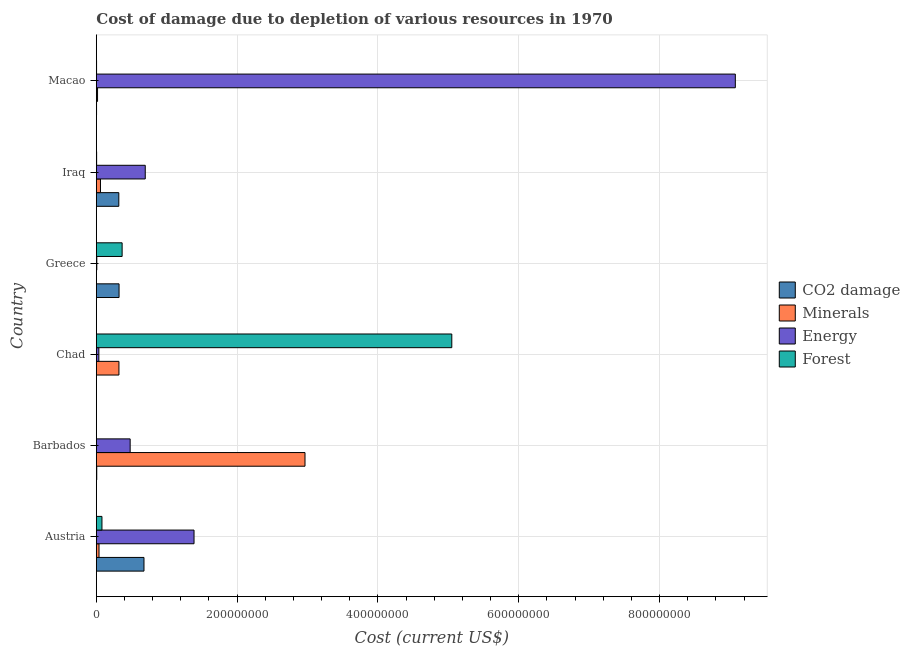Are the number of bars on each tick of the Y-axis equal?
Give a very brief answer. Yes. What is the cost of damage due to depletion of forests in Iraq?
Your answer should be compact. 3.97e+05. Across all countries, what is the maximum cost of damage due to depletion of forests?
Ensure brevity in your answer.  5.05e+08. Across all countries, what is the minimum cost of damage due to depletion of coal?
Provide a short and direct response. 1.66e+05. In which country was the cost of damage due to depletion of coal maximum?
Your response must be concise. Austria. In which country was the cost of damage due to depletion of coal minimum?
Your answer should be compact. Chad. What is the total cost of damage due to depletion of energy in the graph?
Your answer should be very brief. 1.17e+09. What is the difference between the cost of damage due to depletion of minerals in Iraq and that in Macao?
Offer a terse response. 4.15e+06. What is the difference between the cost of damage due to depletion of energy in Austria and the cost of damage due to depletion of forests in Greece?
Offer a terse response. 1.02e+08. What is the average cost of damage due to depletion of coal per country?
Your answer should be compact. 2.21e+07. What is the difference between the cost of damage due to depletion of coal and cost of damage due to depletion of minerals in Iraq?
Your answer should be very brief. 2.61e+07. What is the ratio of the cost of damage due to depletion of coal in Iraq to that in Macao?
Your answer should be compact. 116.43. Is the cost of damage due to depletion of coal in Barbados less than that in Greece?
Your answer should be compact. Yes. Is the difference between the cost of damage due to depletion of minerals in Barbados and Chad greater than the difference between the cost of damage due to depletion of coal in Barbados and Chad?
Offer a terse response. Yes. What is the difference between the highest and the second highest cost of damage due to depletion of coal?
Offer a very short reply. 3.54e+07. What is the difference between the highest and the lowest cost of damage due to depletion of energy?
Keep it short and to the point. 9.07e+08. Is the sum of the cost of damage due to depletion of energy in Chad and Greece greater than the maximum cost of damage due to depletion of minerals across all countries?
Keep it short and to the point. No. What does the 2nd bar from the top in Macao represents?
Keep it short and to the point. Energy. What does the 4th bar from the bottom in Iraq represents?
Offer a very short reply. Forest. Are all the bars in the graph horizontal?
Make the answer very short. Yes. What is the title of the graph?
Keep it short and to the point. Cost of damage due to depletion of various resources in 1970 . What is the label or title of the X-axis?
Give a very brief answer. Cost (current US$). What is the label or title of the Y-axis?
Give a very brief answer. Country. What is the Cost (current US$) in CO2 damage in Austria?
Your answer should be very brief. 6.77e+07. What is the Cost (current US$) in Minerals in Austria?
Ensure brevity in your answer.  3.80e+06. What is the Cost (current US$) in Energy in Austria?
Offer a terse response. 1.39e+08. What is the Cost (current US$) in Forest in Austria?
Your answer should be compact. 7.95e+06. What is the Cost (current US$) in CO2 damage in Barbados?
Ensure brevity in your answer.  5.73e+05. What is the Cost (current US$) of Minerals in Barbados?
Your response must be concise. 2.96e+08. What is the Cost (current US$) of Energy in Barbados?
Keep it short and to the point. 4.80e+07. What is the Cost (current US$) in Forest in Barbados?
Your response must be concise. 3.70e+04. What is the Cost (current US$) of CO2 damage in Chad?
Keep it short and to the point. 1.66e+05. What is the Cost (current US$) of Minerals in Chad?
Offer a terse response. 3.21e+07. What is the Cost (current US$) of Energy in Chad?
Offer a terse response. 3.56e+06. What is the Cost (current US$) of Forest in Chad?
Give a very brief answer. 5.05e+08. What is the Cost (current US$) of CO2 damage in Greece?
Offer a very short reply. 3.23e+07. What is the Cost (current US$) of Minerals in Greece?
Ensure brevity in your answer.  1.05e+05. What is the Cost (current US$) of Energy in Greece?
Your response must be concise. 6.65e+05. What is the Cost (current US$) in Forest in Greece?
Provide a short and direct response. 3.66e+07. What is the Cost (current US$) of CO2 damage in Iraq?
Your answer should be very brief. 3.19e+07. What is the Cost (current US$) of Minerals in Iraq?
Provide a short and direct response. 5.85e+06. What is the Cost (current US$) in Energy in Iraq?
Give a very brief answer. 6.95e+07. What is the Cost (current US$) in Forest in Iraq?
Offer a very short reply. 3.97e+05. What is the Cost (current US$) of CO2 damage in Macao?
Ensure brevity in your answer.  2.74e+05. What is the Cost (current US$) in Minerals in Macao?
Your answer should be compact. 1.70e+06. What is the Cost (current US$) in Energy in Macao?
Your response must be concise. 9.08e+08. What is the Cost (current US$) in Forest in Macao?
Make the answer very short. 3.14e+05. Across all countries, what is the maximum Cost (current US$) in CO2 damage?
Offer a very short reply. 6.77e+07. Across all countries, what is the maximum Cost (current US$) of Minerals?
Offer a very short reply. 2.96e+08. Across all countries, what is the maximum Cost (current US$) in Energy?
Your response must be concise. 9.08e+08. Across all countries, what is the maximum Cost (current US$) in Forest?
Provide a short and direct response. 5.05e+08. Across all countries, what is the minimum Cost (current US$) in CO2 damage?
Ensure brevity in your answer.  1.66e+05. Across all countries, what is the minimum Cost (current US$) in Minerals?
Your answer should be very brief. 1.05e+05. Across all countries, what is the minimum Cost (current US$) in Energy?
Give a very brief answer. 6.65e+05. Across all countries, what is the minimum Cost (current US$) in Forest?
Provide a succinct answer. 3.70e+04. What is the total Cost (current US$) of CO2 damage in the graph?
Offer a very short reply. 1.33e+08. What is the total Cost (current US$) in Minerals in the graph?
Your answer should be very brief. 3.40e+08. What is the total Cost (current US$) in Energy in the graph?
Give a very brief answer. 1.17e+09. What is the total Cost (current US$) of Forest in the graph?
Make the answer very short. 5.50e+08. What is the difference between the Cost (current US$) of CO2 damage in Austria and that in Barbados?
Keep it short and to the point. 6.71e+07. What is the difference between the Cost (current US$) of Minerals in Austria and that in Barbados?
Your response must be concise. -2.93e+08. What is the difference between the Cost (current US$) of Energy in Austria and that in Barbados?
Offer a terse response. 9.07e+07. What is the difference between the Cost (current US$) in Forest in Austria and that in Barbados?
Provide a short and direct response. 7.92e+06. What is the difference between the Cost (current US$) of CO2 damage in Austria and that in Chad?
Provide a short and direct response. 6.75e+07. What is the difference between the Cost (current US$) in Minerals in Austria and that in Chad?
Your response must be concise. -2.83e+07. What is the difference between the Cost (current US$) of Energy in Austria and that in Chad?
Provide a succinct answer. 1.35e+08. What is the difference between the Cost (current US$) in Forest in Austria and that in Chad?
Your answer should be compact. -4.97e+08. What is the difference between the Cost (current US$) in CO2 damage in Austria and that in Greece?
Give a very brief answer. 3.54e+07. What is the difference between the Cost (current US$) in Minerals in Austria and that in Greece?
Provide a short and direct response. 3.69e+06. What is the difference between the Cost (current US$) in Energy in Austria and that in Greece?
Offer a terse response. 1.38e+08. What is the difference between the Cost (current US$) of Forest in Austria and that in Greece?
Give a very brief answer. -2.87e+07. What is the difference between the Cost (current US$) of CO2 damage in Austria and that in Iraq?
Give a very brief answer. 3.58e+07. What is the difference between the Cost (current US$) in Minerals in Austria and that in Iraq?
Ensure brevity in your answer.  -2.06e+06. What is the difference between the Cost (current US$) of Energy in Austria and that in Iraq?
Keep it short and to the point. 6.93e+07. What is the difference between the Cost (current US$) in Forest in Austria and that in Iraq?
Your answer should be very brief. 7.55e+06. What is the difference between the Cost (current US$) of CO2 damage in Austria and that in Macao?
Your answer should be compact. 6.74e+07. What is the difference between the Cost (current US$) in Minerals in Austria and that in Macao?
Your response must be concise. 2.10e+06. What is the difference between the Cost (current US$) of Energy in Austria and that in Macao?
Make the answer very short. -7.69e+08. What is the difference between the Cost (current US$) of Forest in Austria and that in Macao?
Provide a short and direct response. 7.64e+06. What is the difference between the Cost (current US$) of CO2 damage in Barbados and that in Chad?
Provide a succinct answer. 4.06e+05. What is the difference between the Cost (current US$) of Minerals in Barbados and that in Chad?
Keep it short and to the point. 2.64e+08. What is the difference between the Cost (current US$) in Energy in Barbados and that in Chad?
Your response must be concise. 4.45e+07. What is the difference between the Cost (current US$) in Forest in Barbados and that in Chad?
Ensure brevity in your answer.  -5.05e+08. What is the difference between the Cost (current US$) in CO2 damage in Barbados and that in Greece?
Your response must be concise. -3.17e+07. What is the difference between the Cost (current US$) of Minerals in Barbados and that in Greece?
Ensure brevity in your answer.  2.96e+08. What is the difference between the Cost (current US$) in Energy in Barbados and that in Greece?
Offer a terse response. 4.74e+07. What is the difference between the Cost (current US$) of Forest in Barbados and that in Greece?
Keep it short and to the point. -3.66e+07. What is the difference between the Cost (current US$) of CO2 damage in Barbados and that in Iraq?
Offer a very short reply. -3.13e+07. What is the difference between the Cost (current US$) of Minerals in Barbados and that in Iraq?
Give a very brief answer. 2.91e+08. What is the difference between the Cost (current US$) in Energy in Barbados and that in Iraq?
Make the answer very short. -2.14e+07. What is the difference between the Cost (current US$) of Forest in Barbados and that in Iraq?
Make the answer very short. -3.60e+05. What is the difference between the Cost (current US$) of CO2 damage in Barbados and that in Macao?
Ensure brevity in your answer.  2.99e+05. What is the difference between the Cost (current US$) in Minerals in Barbados and that in Macao?
Your answer should be compact. 2.95e+08. What is the difference between the Cost (current US$) in Energy in Barbados and that in Macao?
Provide a succinct answer. -8.60e+08. What is the difference between the Cost (current US$) of Forest in Barbados and that in Macao?
Offer a very short reply. -2.76e+05. What is the difference between the Cost (current US$) in CO2 damage in Chad and that in Greece?
Offer a terse response. -3.21e+07. What is the difference between the Cost (current US$) in Minerals in Chad and that in Greece?
Make the answer very short. 3.20e+07. What is the difference between the Cost (current US$) of Energy in Chad and that in Greece?
Provide a short and direct response. 2.90e+06. What is the difference between the Cost (current US$) in Forest in Chad and that in Greece?
Give a very brief answer. 4.68e+08. What is the difference between the Cost (current US$) of CO2 damage in Chad and that in Iraq?
Ensure brevity in your answer.  -3.17e+07. What is the difference between the Cost (current US$) of Minerals in Chad and that in Iraq?
Your answer should be compact. 2.62e+07. What is the difference between the Cost (current US$) of Energy in Chad and that in Iraq?
Offer a terse response. -6.59e+07. What is the difference between the Cost (current US$) of Forest in Chad and that in Iraq?
Give a very brief answer. 5.05e+08. What is the difference between the Cost (current US$) of CO2 damage in Chad and that in Macao?
Your response must be concise. -1.08e+05. What is the difference between the Cost (current US$) of Minerals in Chad and that in Macao?
Provide a short and direct response. 3.04e+07. What is the difference between the Cost (current US$) in Energy in Chad and that in Macao?
Make the answer very short. -9.04e+08. What is the difference between the Cost (current US$) of Forest in Chad and that in Macao?
Provide a succinct answer. 5.05e+08. What is the difference between the Cost (current US$) in CO2 damage in Greece and that in Iraq?
Ensure brevity in your answer.  3.43e+05. What is the difference between the Cost (current US$) in Minerals in Greece and that in Iraq?
Offer a terse response. -5.75e+06. What is the difference between the Cost (current US$) of Energy in Greece and that in Iraq?
Ensure brevity in your answer.  -6.88e+07. What is the difference between the Cost (current US$) in Forest in Greece and that in Iraq?
Ensure brevity in your answer.  3.62e+07. What is the difference between the Cost (current US$) of CO2 damage in Greece and that in Macao?
Ensure brevity in your answer.  3.20e+07. What is the difference between the Cost (current US$) in Minerals in Greece and that in Macao?
Keep it short and to the point. -1.59e+06. What is the difference between the Cost (current US$) in Energy in Greece and that in Macao?
Offer a very short reply. -9.07e+08. What is the difference between the Cost (current US$) in Forest in Greece and that in Macao?
Provide a short and direct response. 3.63e+07. What is the difference between the Cost (current US$) of CO2 damage in Iraq and that in Macao?
Ensure brevity in your answer.  3.16e+07. What is the difference between the Cost (current US$) in Minerals in Iraq and that in Macao?
Offer a terse response. 4.15e+06. What is the difference between the Cost (current US$) of Energy in Iraq and that in Macao?
Ensure brevity in your answer.  -8.38e+08. What is the difference between the Cost (current US$) in Forest in Iraq and that in Macao?
Provide a short and direct response. 8.39e+04. What is the difference between the Cost (current US$) of CO2 damage in Austria and the Cost (current US$) of Minerals in Barbados?
Your answer should be very brief. -2.29e+08. What is the difference between the Cost (current US$) of CO2 damage in Austria and the Cost (current US$) of Energy in Barbados?
Your response must be concise. 1.96e+07. What is the difference between the Cost (current US$) of CO2 damage in Austria and the Cost (current US$) of Forest in Barbados?
Make the answer very short. 6.76e+07. What is the difference between the Cost (current US$) of Minerals in Austria and the Cost (current US$) of Energy in Barbados?
Your answer should be compact. -4.42e+07. What is the difference between the Cost (current US$) of Minerals in Austria and the Cost (current US$) of Forest in Barbados?
Your answer should be compact. 3.76e+06. What is the difference between the Cost (current US$) of Energy in Austria and the Cost (current US$) of Forest in Barbados?
Your answer should be compact. 1.39e+08. What is the difference between the Cost (current US$) in CO2 damage in Austria and the Cost (current US$) in Minerals in Chad?
Keep it short and to the point. 3.56e+07. What is the difference between the Cost (current US$) of CO2 damage in Austria and the Cost (current US$) of Energy in Chad?
Offer a terse response. 6.41e+07. What is the difference between the Cost (current US$) of CO2 damage in Austria and the Cost (current US$) of Forest in Chad?
Give a very brief answer. -4.37e+08. What is the difference between the Cost (current US$) of Minerals in Austria and the Cost (current US$) of Energy in Chad?
Offer a terse response. 2.34e+05. What is the difference between the Cost (current US$) in Minerals in Austria and the Cost (current US$) in Forest in Chad?
Keep it short and to the point. -5.01e+08. What is the difference between the Cost (current US$) in Energy in Austria and the Cost (current US$) in Forest in Chad?
Offer a very short reply. -3.66e+08. What is the difference between the Cost (current US$) of CO2 damage in Austria and the Cost (current US$) of Minerals in Greece?
Provide a succinct answer. 6.76e+07. What is the difference between the Cost (current US$) of CO2 damage in Austria and the Cost (current US$) of Energy in Greece?
Ensure brevity in your answer.  6.70e+07. What is the difference between the Cost (current US$) in CO2 damage in Austria and the Cost (current US$) in Forest in Greece?
Provide a short and direct response. 3.10e+07. What is the difference between the Cost (current US$) of Minerals in Austria and the Cost (current US$) of Energy in Greece?
Make the answer very short. 3.13e+06. What is the difference between the Cost (current US$) of Minerals in Austria and the Cost (current US$) of Forest in Greece?
Offer a very short reply. -3.28e+07. What is the difference between the Cost (current US$) in Energy in Austria and the Cost (current US$) in Forest in Greece?
Provide a short and direct response. 1.02e+08. What is the difference between the Cost (current US$) in CO2 damage in Austria and the Cost (current US$) in Minerals in Iraq?
Your answer should be compact. 6.18e+07. What is the difference between the Cost (current US$) in CO2 damage in Austria and the Cost (current US$) in Energy in Iraq?
Ensure brevity in your answer.  -1.80e+06. What is the difference between the Cost (current US$) of CO2 damage in Austria and the Cost (current US$) of Forest in Iraq?
Your answer should be compact. 6.73e+07. What is the difference between the Cost (current US$) in Minerals in Austria and the Cost (current US$) in Energy in Iraq?
Your answer should be compact. -6.57e+07. What is the difference between the Cost (current US$) in Minerals in Austria and the Cost (current US$) in Forest in Iraq?
Provide a short and direct response. 3.40e+06. What is the difference between the Cost (current US$) in Energy in Austria and the Cost (current US$) in Forest in Iraq?
Your answer should be compact. 1.38e+08. What is the difference between the Cost (current US$) in CO2 damage in Austria and the Cost (current US$) in Minerals in Macao?
Make the answer very short. 6.60e+07. What is the difference between the Cost (current US$) of CO2 damage in Austria and the Cost (current US$) of Energy in Macao?
Make the answer very short. -8.40e+08. What is the difference between the Cost (current US$) of CO2 damage in Austria and the Cost (current US$) of Forest in Macao?
Offer a very short reply. 6.74e+07. What is the difference between the Cost (current US$) of Minerals in Austria and the Cost (current US$) of Energy in Macao?
Provide a short and direct response. -9.04e+08. What is the difference between the Cost (current US$) of Minerals in Austria and the Cost (current US$) of Forest in Macao?
Ensure brevity in your answer.  3.48e+06. What is the difference between the Cost (current US$) of Energy in Austria and the Cost (current US$) of Forest in Macao?
Offer a very short reply. 1.38e+08. What is the difference between the Cost (current US$) in CO2 damage in Barbados and the Cost (current US$) in Minerals in Chad?
Give a very brief answer. -3.15e+07. What is the difference between the Cost (current US$) in CO2 damage in Barbados and the Cost (current US$) in Energy in Chad?
Offer a very short reply. -2.99e+06. What is the difference between the Cost (current US$) of CO2 damage in Barbados and the Cost (current US$) of Forest in Chad?
Keep it short and to the point. -5.04e+08. What is the difference between the Cost (current US$) in Minerals in Barbados and the Cost (current US$) in Energy in Chad?
Ensure brevity in your answer.  2.93e+08. What is the difference between the Cost (current US$) of Minerals in Barbados and the Cost (current US$) of Forest in Chad?
Offer a very short reply. -2.09e+08. What is the difference between the Cost (current US$) in Energy in Barbados and the Cost (current US$) in Forest in Chad?
Give a very brief answer. -4.57e+08. What is the difference between the Cost (current US$) of CO2 damage in Barbados and the Cost (current US$) of Minerals in Greece?
Your answer should be compact. 4.68e+05. What is the difference between the Cost (current US$) of CO2 damage in Barbados and the Cost (current US$) of Energy in Greece?
Offer a terse response. -9.19e+04. What is the difference between the Cost (current US$) of CO2 damage in Barbados and the Cost (current US$) of Forest in Greece?
Your answer should be compact. -3.61e+07. What is the difference between the Cost (current US$) in Minerals in Barbados and the Cost (current US$) in Energy in Greece?
Offer a very short reply. 2.96e+08. What is the difference between the Cost (current US$) of Minerals in Barbados and the Cost (current US$) of Forest in Greece?
Offer a terse response. 2.60e+08. What is the difference between the Cost (current US$) of Energy in Barbados and the Cost (current US$) of Forest in Greece?
Your answer should be compact. 1.14e+07. What is the difference between the Cost (current US$) of CO2 damage in Barbados and the Cost (current US$) of Minerals in Iraq?
Your answer should be compact. -5.28e+06. What is the difference between the Cost (current US$) of CO2 damage in Barbados and the Cost (current US$) of Energy in Iraq?
Offer a terse response. -6.89e+07. What is the difference between the Cost (current US$) of CO2 damage in Barbados and the Cost (current US$) of Forest in Iraq?
Your answer should be very brief. 1.75e+05. What is the difference between the Cost (current US$) in Minerals in Barbados and the Cost (current US$) in Energy in Iraq?
Make the answer very short. 2.27e+08. What is the difference between the Cost (current US$) of Minerals in Barbados and the Cost (current US$) of Forest in Iraq?
Give a very brief answer. 2.96e+08. What is the difference between the Cost (current US$) of Energy in Barbados and the Cost (current US$) of Forest in Iraq?
Provide a succinct answer. 4.76e+07. What is the difference between the Cost (current US$) of CO2 damage in Barbados and the Cost (current US$) of Minerals in Macao?
Your answer should be compact. -1.12e+06. What is the difference between the Cost (current US$) in CO2 damage in Barbados and the Cost (current US$) in Energy in Macao?
Make the answer very short. -9.07e+08. What is the difference between the Cost (current US$) of CO2 damage in Barbados and the Cost (current US$) of Forest in Macao?
Provide a succinct answer. 2.59e+05. What is the difference between the Cost (current US$) in Minerals in Barbados and the Cost (current US$) in Energy in Macao?
Offer a terse response. -6.11e+08. What is the difference between the Cost (current US$) in Minerals in Barbados and the Cost (current US$) in Forest in Macao?
Your answer should be compact. 2.96e+08. What is the difference between the Cost (current US$) of Energy in Barbados and the Cost (current US$) of Forest in Macao?
Provide a short and direct response. 4.77e+07. What is the difference between the Cost (current US$) in CO2 damage in Chad and the Cost (current US$) in Minerals in Greece?
Ensure brevity in your answer.  6.16e+04. What is the difference between the Cost (current US$) of CO2 damage in Chad and the Cost (current US$) of Energy in Greece?
Your answer should be compact. -4.98e+05. What is the difference between the Cost (current US$) of CO2 damage in Chad and the Cost (current US$) of Forest in Greece?
Your answer should be compact. -3.65e+07. What is the difference between the Cost (current US$) in Minerals in Chad and the Cost (current US$) in Energy in Greece?
Offer a very short reply. 3.14e+07. What is the difference between the Cost (current US$) in Minerals in Chad and the Cost (current US$) in Forest in Greece?
Ensure brevity in your answer.  -4.53e+06. What is the difference between the Cost (current US$) in Energy in Chad and the Cost (current US$) in Forest in Greece?
Your answer should be very brief. -3.31e+07. What is the difference between the Cost (current US$) of CO2 damage in Chad and the Cost (current US$) of Minerals in Iraq?
Offer a very short reply. -5.69e+06. What is the difference between the Cost (current US$) in CO2 damage in Chad and the Cost (current US$) in Energy in Iraq?
Keep it short and to the point. -6.93e+07. What is the difference between the Cost (current US$) in CO2 damage in Chad and the Cost (current US$) in Forest in Iraq?
Provide a short and direct response. -2.31e+05. What is the difference between the Cost (current US$) of Minerals in Chad and the Cost (current US$) of Energy in Iraq?
Keep it short and to the point. -3.74e+07. What is the difference between the Cost (current US$) in Minerals in Chad and the Cost (current US$) in Forest in Iraq?
Your answer should be compact. 3.17e+07. What is the difference between the Cost (current US$) in Energy in Chad and the Cost (current US$) in Forest in Iraq?
Ensure brevity in your answer.  3.17e+06. What is the difference between the Cost (current US$) in CO2 damage in Chad and the Cost (current US$) in Minerals in Macao?
Offer a very short reply. -1.53e+06. What is the difference between the Cost (current US$) of CO2 damage in Chad and the Cost (current US$) of Energy in Macao?
Ensure brevity in your answer.  -9.07e+08. What is the difference between the Cost (current US$) in CO2 damage in Chad and the Cost (current US$) in Forest in Macao?
Offer a very short reply. -1.47e+05. What is the difference between the Cost (current US$) in Minerals in Chad and the Cost (current US$) in Energy in Macao?
Offer a terse response. -8.76e+08. What is the difference between the Cost (current US$) of Minerals in Chad and the Cost (current US$) of Forest in Macao?
Offer a terse response. 3.18e+07. What is the difference between the Cost (current US$) of Energy in Chad and the Cost (current US$) of Forest in Macao?
Keep it short and to the point. 3.25e+06. What is the difference between the Cost (current US$) of CO2 damage in Greece and the Cost (current US$) of Minerals in Iraq?
Your answer should be very brief. 2.64e+07. What is the difference between the Cost (current US$) of CO2 damage in Greece and the Cost (current US$) of Energy in Iraq?
Provide a short and direct response. -3.72e+07. What is the difference between the Cost (current US$) of CO2 damage in Greece and the Cost (current US$) of Forest in Iraq?
Make the answer very short. 3.19e+07. What is the difference between the Cost (current US$) in Minerals in Greece and the Cost (current US$) in Energy in Iraq?
Your response must be concise. -6.94e+07. What is the difference between the Cost (current US$) in Minerals in Greece and the Cost (current US$) in Forest in Iraq?
Offer a terse response. -2.93e+05. What is the difference between the Cost (current US$) in Energy in Greece and the Cost (current US$) in Forest in Iraq?
Give a very brief answer. 2.67e+05. What is the difference between the Cost (current US$) of CO2 damage in Greece and the Cost (current US$) of Minerals in Macao?
Your answer should be compact. 3.06e+07. What is the difference between the Cost (current US$) in CO2 damage in Greece and the Cost (current US$) in Energy in Macao?
Ensure brevity in your answer.  -8.75e+08. What is the difference between the Cost (current US$) of CO2 damage in Greece and the Cost (current US$) of Forest in Macao?
Your answer should be very brief. 3.19e+07. What is the difference between the Cost (current US$) in Minerals in Greece and the Cost (current US$) in Energy in Macao?
Ensure brevity in your answer.  -9.08e+08. What is the difference between the Cost (current US$) in Minerals in Greece and the Cost (current US$) in Forest in Macao?
Make the answer very short. -2.09e+05. What is the difference between the Cost (current US$) in Energy in Greece and the Cost (current US$) in Forest in Macao?
Offer a terse response. 3.51e+05. What is the difference between the Cost (current US$) in CO2 damage in Iraq and the Cost (current US$) in Minerals in Macao?
Ensure brevity in your answer.  3.02e+07. What is the difference between the Cost (current US$) in CO2 damage in Iraq and the Cost (current US$) in Energy in Macao?
Give a very brief answer. -8.76e+08. What is the difference between the Cost (current US$) of CO2 damage in Iraq and the Cost (current US$) of Forest in Macao?
Provide a short and direct response. 3.16e+07. What is the difference between the Cost (current US$) of Minerals in Iraq and the Cost (current US$) of Energy in Macao?
Your answer should be compact. -9.02e+08. What is the difference between the Cost (current US$) of Minerals in Iraq and the Cost (current US$) of Forest in Macao?
Give a very brief answer. 5.54e+06. What is the difference between the Cost (current US$) in Energy in Iraq and the Cost (current US$) in Forest in Macao?
Your answer should be compact. 6.92e+07. What is the average Cost (current US$) in CO2 damage per country?
Offer a terse response. 2.21e+07. What is the average Cost (current US$) of Minerals per country?
Give a very brief answer. 5.67e+07. What is the average Cost (current US$) in Energy per country?
Provide a succinct answer. 1.95e+08. What is the average Cost (current US$) of Forest per country?
Offer a terse response. 9.17e+07. What is the difference between the Cost (current US$) in CO2 damage and Cost (current US$) in Minerals in Austria?
Your answer should be very brief. 6.39e+07. What is the difference between the Cost (current US$) of CO2 damage and Cost (current US$) of Energy in Austria?
Ensure brevity in your answer.  -7.11e+07. What is the difference between the Cost (current US$) in CO2 damage and Cost (current US$) in Forest in Austria?
Give a very brief answer. 5.97e+07. What is the difference between the Cost (current US$) in Minerals and Cost (current US$) in Energy in Austria?
Keep it short and to the point. -1.35e+08. What is the difference between the Cost (current US$) of Minerals and Cost (current US$) of Forest in Austria?
Your answer should be compact. -4.16e+06. What is the difference between the Cost (current US$) of Energy and Cost (current US$) of Forest in Austria?
Your answer should be compact. 1.31e+08. What is the difference between the Cost (current US$) in CO2 damage and Cost (current US$) in Minerals in Barbados?
Ensure brevity in your answer.  -2.96e+08. What is the difference between the Cost (current US$) in CO2 damage and Cost (current US$) in Energy in Barbados?
Provide a short and direct response. -4.75e+07. What is the difference between the Cost (current US$) in CO2 damage and Cost (current US$) in Forest in Barbados?
Provide a short and direct response. 5.36e+05. What is the difference between the Cost (current US$) in Minerals and Cost (current US$) in Energy in Barbados?
Provide a succinct answer. 2.48e+08. What is the difference between the Cost (current US$) of Minerals and Cost (current US$) of Forest in Barbados?
Keep it short and to the point. 2.96e+08. What is the difference between the Cost (current US$) in Energy and Cost (current US$) in Forest in Barbados?
Keep it short and to the point. 4.80e+07. What is the difference between the Cost (current US$) in CO2 damage and Cost (current US$) in Minerals in Chad?
Provide a succinct answer. -3.19e+07. What is the difference between the Cost (current US$) in CO2 damage and Cost (current US$) in Energy in Chad?
Your response must be concise. -3.40e+06. What is the difference between the Cost (current US$) in CO2 damage and Cost (current US$) in Forest in Chad?
Give a very brief answer. -5.05e+08. What is the difference between the Cost (current US$) of Minerals and Cost (current US$) of Energy in Chad?
Your answer should be compact. 2.85e+07. What is the difference between the Cost (current US$) in Minerals and Cost (current US$) in Forest in Chad?
Your response must be concise. -4.73e+08. What is the difference between the Cost (current US$) of Energy and Cost (current US$) of Forest in Chad?
Ensure brevity in your answer.  -5.01e+08. What is the difference between the Cost (current US$) of CO2 damage and Cost (current US$) of Minerals in Greece?
Make the answer very short. 3.22e+07. What is the difference between the Cost (current US$) of CO2 damage and Cost (current US$) of Energy in Greece?
Your response must be concise. 3.16e+07. What is the difference between the Cost (current US$) in CO2 damage and Cost (current US$) in Forest in Greece?
Your response must be concise. -4.37e+06. What is the difference between the Cost (current US$) of Minerals and Cost (current US$) of Energy in Greece?
Provide a short and direct response. -5.60e+05. What is the difference between the Cost (current US$) of Minerals and Cost (current US$) of Forest in Greece?
Give a very brief answer. -3.65e+07. What is the difference between the Cost (current US$) in Energy and Cost (current US$) in Forest in Greece?
Your response must be concise. -3.60e+07. What is the difference between the Cost (current US$) of CO2 damage and Cost (current US$) of Minerals in Iraq?
Your answer should be very brief. 2.61e+07. What is the difference between the Cost (current US$) in CO2 damage and Cost (current US$) in Energy in Iraq?
Your answer should be compact. -3.76e+07. What is the difference between the Cost (current US$) of CO2 damage and Cost (current US$) of Forest in Iraq?
Keep it short and to the point. 3.15e+07. What is the difference between the Cost (current US$) in Minerals and Cost (current US$) in Energy in Iraq?
Provide a short and direct response. -6.36e+07. What is the difference between the Cost (current US$) in Minerals and Cost (current US$) in Forest in Iraq?
Offer a very short reply. 5.45e+06. What is the difference between the Cost (current US$) in Energy and Cost (current US$) in Forest in Iraq?
Provide a succinct answer. 6.91e+07. What is the difference between the Cost (current US$) in CO2 damage and Cost (current US$) in Minerals in Macao?
Make the answer very short. -1.42e+06. What is the difference between the Cost (current US$) in CO2 damage and Cost (current US$) in Energy in Macao?
Your answer should be compact. -9.07e+08. What is the difference between the Cost (current US$) of CO2 damage and Cost (current US$) of Forest in Macao?
Make the answer very short. -3.94e+04. What is the difference between the Cost (current US$) of Minerals and Cost (current US$) of Energy in Macao?
Make the answer very short. -9.06e+08. What is the difference between the Cost (current US$) of Minerals and Cost (current US$) of Forest in Macao?
Make the answer very short. 1.38e+06. What is the difference between the Cost (current US$) of Energy and Cost (current US$) of Forest in Macao?
Ensure brevity in your answer.  9.07e+08. What is the ratio of the Cost (current US$) in CO2 damage in Austria to that in Barbados?
Your answer should be compact. 118.15. What is the ratio of the Cost (current US$) of Minerals in Austria to that in Barbados?
Make the answer very short. 0.01. What is the ratio of the Cost (current US$) in Energy in Austria to that in Barbados?
Offer a very short reply. 2.89. What is the ratio of the Cost (current US$) of Forest in Austria to that in Barbados?
Your answer should be very brief. 214.76. What is the ratio of the Cost (current US$) of CO2 damage in Austria to that in Chad?
Your answer should be compact. 406.59. What is the ratio of the Cost (current US$) in Minerals in Austria to that in Chad?
Your answer should be very brief. 0.12. What is the ratio of the Cost (current US$) of Energy in Austria to that in Chad?
Keep it short and to the point. 38.95. What is the ratio of the Cost (current US$) in Forest in Austria to that in Chad?
Make the answer very short. 0.02. What is the ratio of the Cost (current US$) in CO2 damage in Austria to that in Greece?
Your answer should be very brief. 2.1. What is the ratio of the Cost (current US$) in Minerals in Austria to that in Greece?
Your answer should be very brief. 36.22. What is the ratio of the Cost (current US$) in Energy in Austria to that in Greece?
Keep it short and to the point. 208.78. What is the ratio of the Cost (current US$) in Forest in Austria to that in Greece?
Offer a very short reply. 0.22. What is the ratio of the Cost (current US$) in CO2 damage in Austria to that in Iraq?
Provide a short and direct response. 2.12. What is the ratio of the Cost (current US$) in Minerals in Austria to that in Iraq?
Ensure brevity in your answer.  0.65. What is the ratio of the Cost (current US$) in Energy in Austria to that in Iraq?
Give a very brief answer. 2. What is the ratio of the Cost (current US$) of Forest in Austria to that in Iraq?
Provide a succinct answer. 20.01. What is the ratio of the Cost (current US$) in CO2 damage in Austria to that in Macao?
Your answer should be very brief. 246.86. What is the ratio of the Cost (current US$) in Minerals in Austria to that in Macao?
Make the answer very short. 2.24. What is the ratio of the Cost (current US$) in Energy in Austria to that in Macao?
Give a very brief answer. 0.15. What is the ratio of the Cost (current US$) in Forest in Austria to that in Macao?
Keep it short and to the point. 25.37. What is the ratio of the Cost (current US$) in CO2 damage in Barbados to that in Chad?
Offer a very short reply. 3.44. What is the ratio of the Cost (current US$) of Minerals in Barbados to that in Chad?
Make the answer very short. 9.24. What is the ratio of the Cost (current US$) of Energy in Barbados to that in Chad?
Provide a succinct answer. 13.48. What is the ratio of the Cost (current US$) of Forest in Barbados to that in Chad?
Provide a succinct answer. 0. What is the ratio of the Cost (current US$) of CO2 damage in Barbados to that in Greece?
Provide a succinct answer. 0.02. What is the ratio of the Cost (current US$) in Minerals in Barbados to that in Greece?
Provide a succinct answer. 2827.66. What is the ratio of the Cost (current US$) of Energy in Barbados to that in Greece?
Offer a very short reply. 72.27. What is the ratio of the Cost (current US$) of CO2 damage in Barbados to that in Iraq?
Ensure brevity in your answer.  0.02. What is the ratio of the Cost (current US$) in Minerals in Barbados to that in Iraq?
Your answer should be very brief. 50.65. What is the ratio of the Cost (current US$) in Energy in Barbados to that in Iraq?
Offer a very short reply. 0.69. What is the ratio of the Cost (current US$) in Forest in Barbados to that in Iraq?
Provide a short and direct response. 0.09. What is the ratio of the Cost (current US$) in CO2 damage in Barbados to that in Macao?
Provide a short and direct response. 2.09. What is the ratio of the Cost (current US$) of Minerals in Barbados to that in Macao?
Ensure brevity in your answer.  174.65. What is the ratio of the Cost (current US$) in Energy in Barbados to that in Macao?
Offer a terse response. 0.05. What is the ratio of the Cost (current US$) in Forest in Barbados to that in Macao?
Ensure brevity in your answer.  0.12. What is the ratio of the Cost (current US$) in CO2 damage in Chad to that in Greece?
Offer a very short reply. 0.01. What is the ratio of the Cost (current US$) of Minerals in Chad to that in Greece?
Your response must be concise. 306.15. What is the ratio of the Cost (current US$) of Energy in Chad to that in Greece?
Offer a terse response. 5.36. What is the ratio of the Cost (current US$) of Forest in Chad to that in Greece?
Provide a succinct answer. 13.79. What is the ratio of the Cost (current US$) in CO2 damage in Chad to that in Iraq?
Your response must be concise. 0.01. What is the ratio of the Cost (current US$) of Minerals in Chad to that in Iraq?
Keep it short and to the point. 5.48. What is the ratio of the Cost (current US$) of Energy in Chad to that in Iraq?
Your answer should be very brief. 0.05. What is the ratio of the Cost (current US$) of Forest in Chad to that in Iraq?
Your response must be concise. 1270.45. What is the ratio of the Cost (current US$) in CO2 damage in Chad to that in Macao?
Make the answer very short. 0.61. What is the ratio of the Cost (current US$) of Minerals in Chad to that in Macao?
Provide a succinct answer. 18.91. What is the ratio of the Cost (current US$) of Energy in Chad to that in Macao?
Your answer should be compact. 0. What is the ratio of the Cost (current US$) of Forest in Chad to that in Macao?
Ensure brevity in your answer.  1610.52. What is the ratio of the Cost (current US$) of CO2 damage in Greece to that in Iraq?
Offer a very short reply. 1.01. What is the ratio of the Cost (current US$) in Minerals in Greece to that in Iraq?
Make the answer very short. 0.02. What is the ratio of the Cost (current US$) of Energy in Greece to that in Iraq?
Your response must be concise. 0.01. What is the ratio of the Cost (current US$) in Forest in Greece to that in Iraq?
Offer a very short reply. 92.15. What is the ratio of the Cost (current US$) in CO2 damage in Greece to that in Macao?
Your response must be concise. 117.68. What is the ratio of the Cost (current US$) in Minerals in Greece to that in Macao?
Keep it short and to the point. 0.06. What is the ratio of the Cost (current US$) in Energy in Greece to that in Macao?
Make the answer very short. 0. What is the ratio of the Cost (current US$) in Forest in Greece to that in Macao?
Offer a very short reply. 116.82. What is the ratio of the Cost (current US$) of CO2 damage in Iraq to that in Macao?
Give a very brief answer. 116.43. What is the ratio of the Cost (current US$) in Minerals in Iraq to that in Macao?
Your answer should be compact. 3.45. What is the ratio of the Cost (current US$) of Energy in Iraq to that in Macao?
Your answer should be very brief. 0.08. What is the ratio of the Cost (current US$) of Forest in Iraq to that in Macao?
Give a very brief answer. 1.27. What is the difference between the highest and the second highest Cost (current US$) of CO2 damage?
Give a very brief answer. 3.54e+07. What is the difference between the highest and the second highest Cost (current US$) in Minerals?
Your answer should be very brief. 2.64e+08. What is the difference between the highest and the second highest Cost (current US$) in Energy?
Your answer should be very brief. 7.69e+08. What is the difference between the highest and the second highest Cost (current US$) in Forest?
Your response must be concise. 4.68e+08. What is the difference between the highest and the lowest Cost (current US$) of CO2 damage?
Provide a short and direct response. 6.75e+07. What is the difference between the highest and the lowest Cost (current US$) of Minerals?
Keep it short and to the point. 2.96e+08. What is the difference between the highest and the lowest Cost (current US$) in Energy?
Make the answer very short. 9.07e+08. What is the difference between the highest and the lowest Cost (current US$) in Forest?
Offer a terse response. 5.05e+08. 